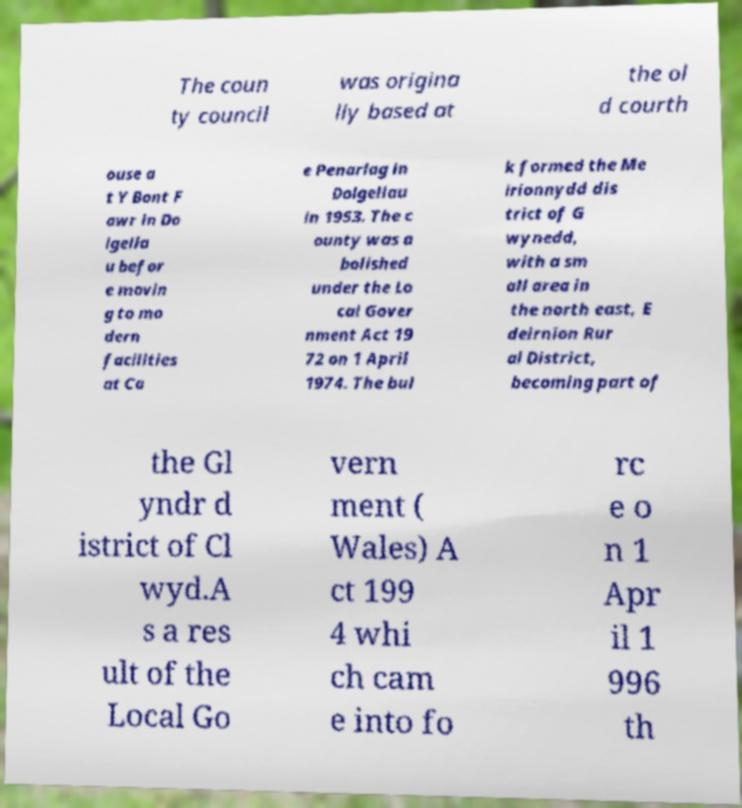What messages or text are displayed in this image? I need them in a readable, typed format. The coun ty council was origina lly based at the ol d courth ouse a t Y Bont F awr in Do lgella u befor e movin g to mo dern facilities at Ca e Penarlag in Dolgellau in 1953. The c ounty was a bolished under the Lo cal Gover nment Act 19 72 on 1 April 1974. The bul k formed the Me irionnydd dis trict of G wynedd, with a sm all area in the north east, E deirnion Rur al District, becoming part of the Gl yndr d istrict of Cl wyd.A s a res ult of the Local Go vern ment ( Wales) A ct 199 4 whi ch cam e into fo rc e o n 1 Apr il 1 996 th 